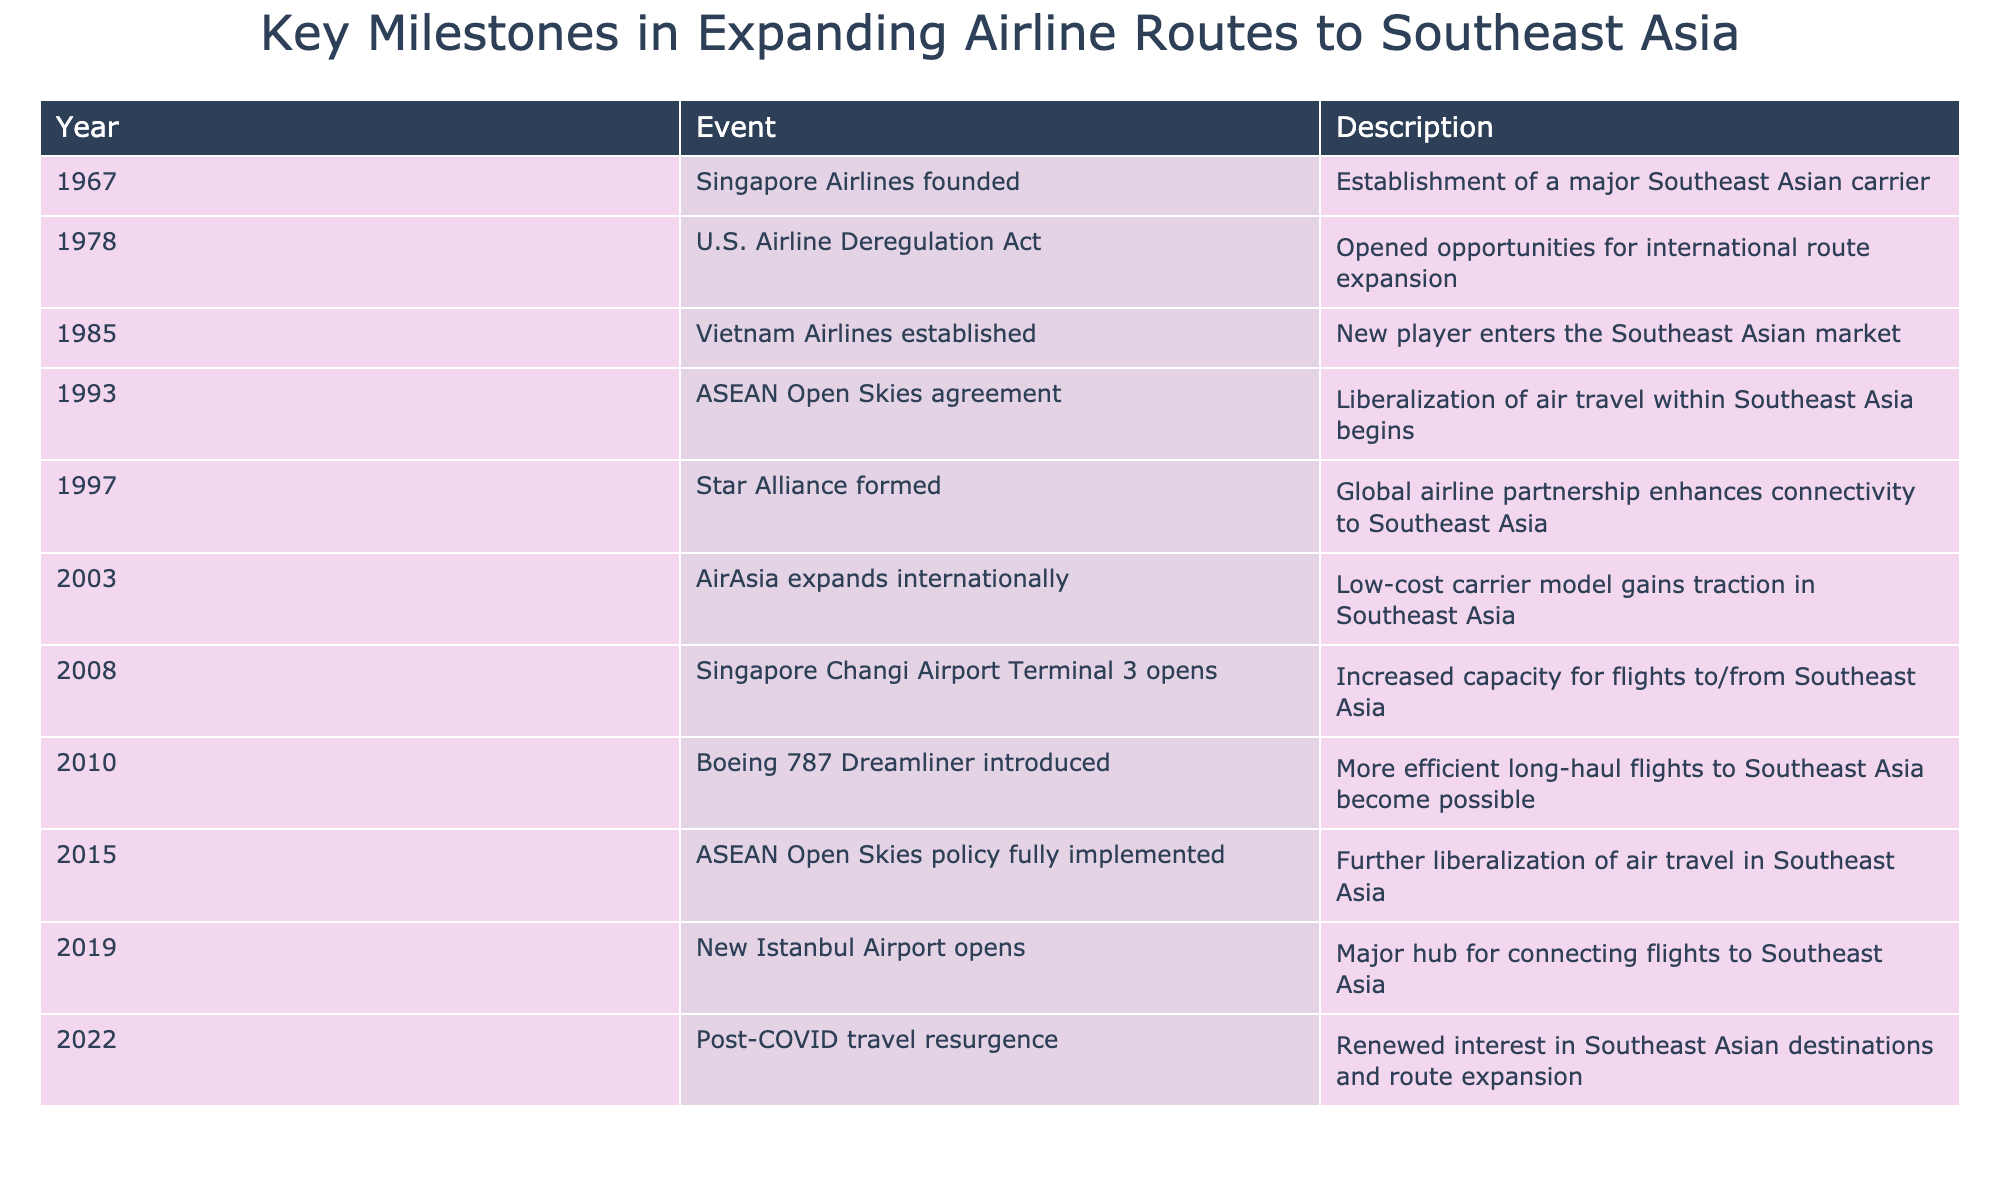What year was Singapore Airlines founded? According to the table, the founding year of Singapore Airlines is listed under the 'Year' column for the corresponding event. It is specifically mentioned in the first row that Singapore Airlines was founded in 1967.
Answer: 1967 What major airline partnership was formed in 1997? The table specifies that the Star Alliance was formed in 1997, as noted in the Event column for that year.
Answer: Star Alliance How many years passed between the establishment of Vietnam Airlines and the full implementation of the ASEAN Open Skies policy? Vietnam Airlines was established in 1985 and the ASEAN Open Skies policy was fully implemented in 2015. To find the difference, subtract 1985 from 2015, which equals 30 years.
Answer: 30 years Did the introduction of the Boeing 787 Dreamliner influence long-haul flights to Southeast Asia? The table indicates that the Boeing 787 Dreamliner was introduced in 2010 and that it made more efficient long-haul flights to Southeast Asia possible, suggesting that its introduction had a positive influence.
Answer: Yes What were the consecutive years when Singapore Changi Airport Terminal 3 opened and the ASEAN Open Skies policy was fully implemented? According to the table, Terminal 3 opened in 2008 and the ASEAN Open Skies policy was fully implemented in 2015. Therefore, the consecutive years are 2008 and 2015.
Answer: 2008 and 2015 How many significant milestones occurred between 2000 and 2020? The table lists 11 events within this range - starting from 2003 (AirAsia expands internationally) until the post-COVID travel resurgence in 2022. This makes for a total of 8 significant milestones during this period from 2003 to 2022.
Answer: 8 milestones Was the ASEAN Open Skies agreement introduced before or after the establishment of Singapore Airlines? By examining the table, we find the ASEAN Open Skies agreement in 1993, while Singapore Airlines was founded in 1967; thus, the agreement was introduced after the establishment of the airline.
Answer: After What was the trend of airline developments in the Southeast Asia region from 2000 to 2022? Based on the table, from 2000 to 2022, significant developments include the rise of low-cost carriers (AirAsia's international expansion), the opening of major airports (New Istanbul Airport, Changi's Terminal 3), and the resurgence of travel post-COVID, indicating a trend towards increased connectivity and travel opportunities.
Answer: Increased connectivity and travel opportunities 